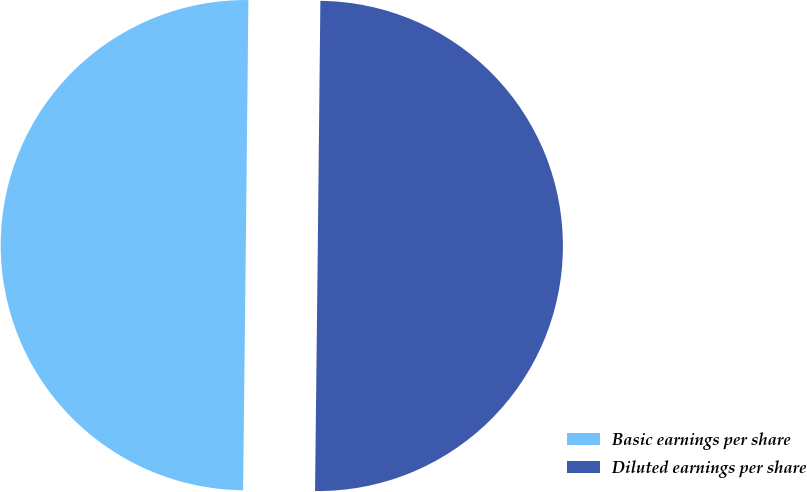Convert chart. <chart><loc_0><loc_0><loc_500><loc_500><pie_chart><fcel>Basic earnings per share<fcel>Diluted earnings per share<nl><fcel>49.99%<fcel>50.01%<nl></chart> 